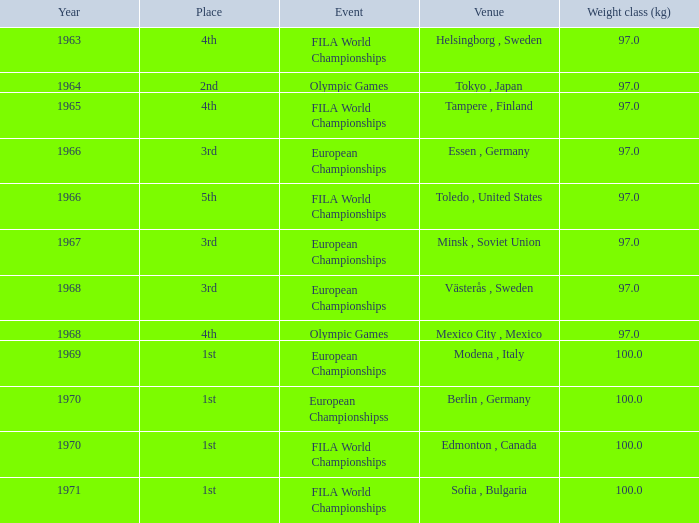What is the lowest year that has edmonton, canada as the venue with a weight class (kg) greater than 100? None. 